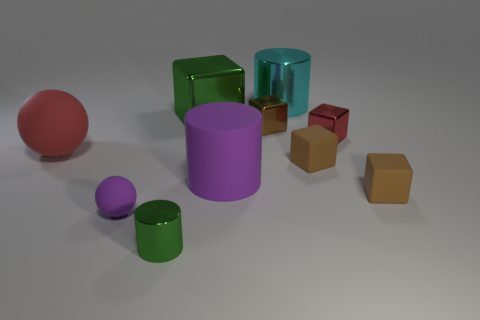Subtract all cyan cylinders. How many brown cubes are left? 3 Subtract all red cubes. How many cubes are left? 4 Subtract all red metallic blocks. How many blocks are left? 4 Subtract all cyan spheres. Subtract all green blocks. How many spheres are left? 2 Subtract all cylinders. How many objects are left? 7 Subtract all small red matte spheres. Subtract all tiny purple rubber things. How many objects are left? 9 Add 8 purple matte spheres. How many purple matte spheres are left? 9 Add 4 tiny brown objects. How many tiny brown objects exist? 7 Subtract 0 gray cylinders. How many objects are left? 10 